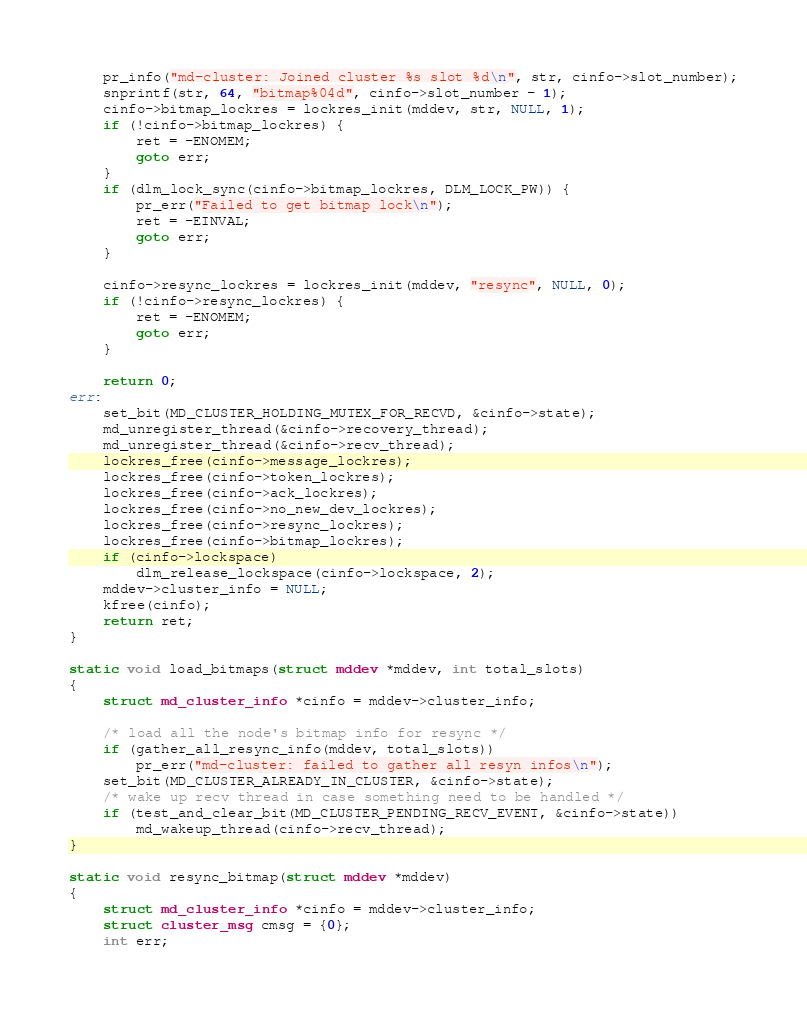Convert code to text. <code><loc_0><loc_0><loc_500><loc_500><_C_>	pr_info("md-cluster: Joined cluster %s slot %d\n", str, cinfo->slot_number);
	snprintf(str, 64, "bitmap%04d", cinfo->slot_number - 1);
	cinfo->bitmap_lockres = lockres_init(mddev, str, NULL, 1);
	if (!cinfo->bitmap_lockres) {
		ret = -ENOMEM;
		goto err;
	}
	if (dlm_lock_sync(cinfo->bitmap_lockres, DLM_LOCK_PW)) {
		pr_err("Failed to get bitmap lock\n");
		ret = -EINVAL;
		goto err;
	}

	cinfo->resync_lockres = lockres_init(mddev, "resync", NULL, 0);
	if (!cinfo->resync_lockres) {
		ret = -ENOMEM;
		goto err;
	}

	return 0;
err:
	set_bit(MD_CLUSTER_HOLDING_MUTEX_FOR_RECVD, &cinfo->state);
	md_unregister_thread(&cinfo->recovery_thread);
	md_unregister_thread(&cinfo->recv_thread);
	lockres_free(cinfo->message_lockres);
	lockres_free(cinfo->token_lockres);
	lockres_free(cinfo->ack_lockres);
	lockres_free(cinfo->no_new_dev_lockres);
	lockres_free(cinfo->resync_lockres);
	lockres_free(cinfo->bitmap_lockres);
	if (cinfo->lockspace)
		dlm_release_lockspace(cinfo->lockspace, 2);
	mddev->cluster_info = NULL;
	kfree(cinfo);
	return ret;
}

static void load_bitmaps(struct mddev *mddev, int total_slots)
{
	struct md_cluster_info *cinfo = mddev->cluster_info;

	/* load all the node's bitmap info for resync */
	if (gather_all_resync_info(mddev, total_slots))
		pr_err("md-cluster: failed to gather all resyn infos\n");
	set_bit(MD_CLUSTER_ALREADY_IN_CLUSTER, &cinfo->state);
	/* wake up recv thread in case something need to be handled */
	if (test_and_clear_bit(MD_CLUSTER_PENDING_RECV_EVENT, &cinfo->state))
		md_wakeup_thread(cinfo->recv_thread);
}

static void resync_bitmap(struct mddev *mddev)
{
	struct md_cluster_info *cinfo = mddev->cluster_info;
	struct cluster_msg cmsg = {0};
	int err;
</code> 